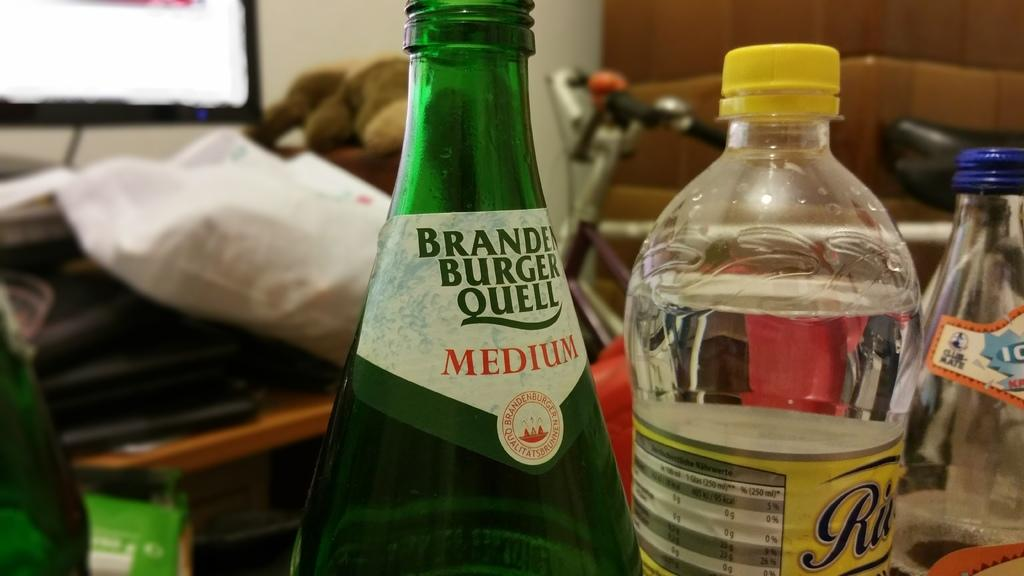<image>
Relay a brief, clear account of the picture shown. A bottle of water and a bottle of Braden Burger Queel Medium sits on a surface. 